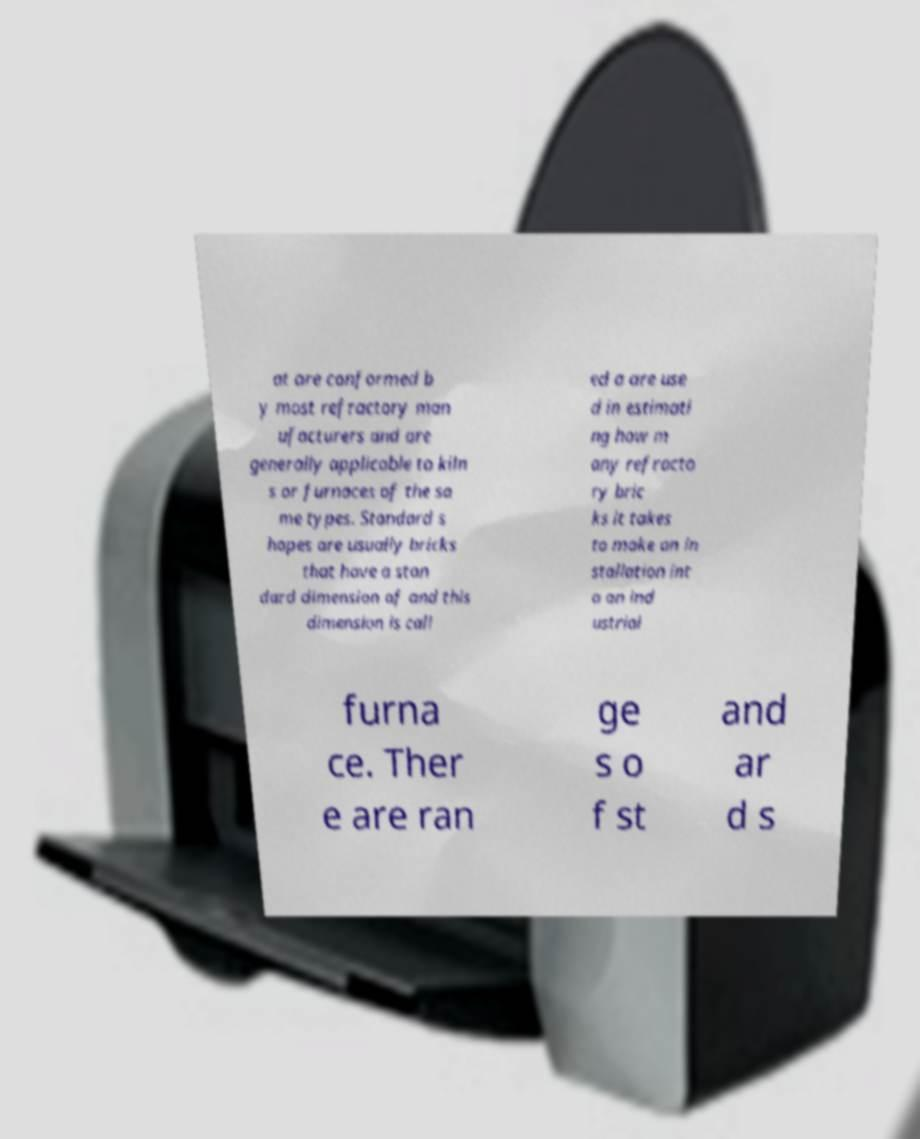What messages or text are displayed in this image? I need them in a readable, typed format. at are conformed b y most refractory man ufacturers and are generally applicable to kiln s or furnaces of the sa me types. Standard s hapes are usually bricks that have a stan dard dimension of and this dimension is call ed a are use d in estimati ng how m any refracto ry bric ks it takes to make an in stallation int o an ind ustrial furna ce. Ther e are ran ge s o f st and ar d s 